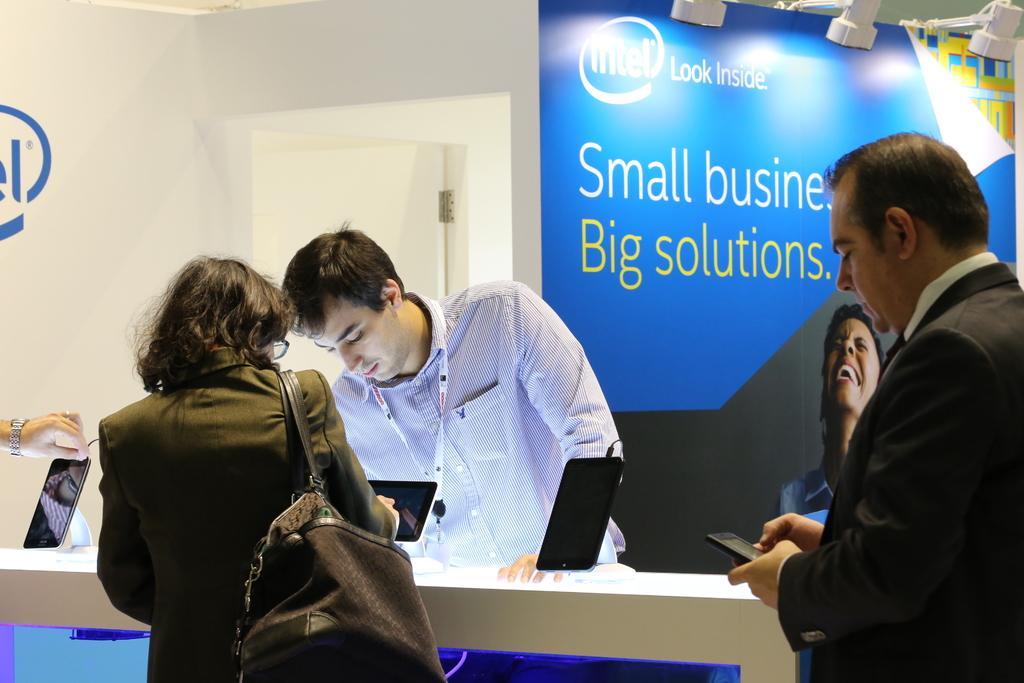In one or two sentences, can you explain what this image depicts? In this picture we can see a woman wearing bag. There are two people holding phone in their hands on the left and right side. A man is standing. There are few lights and a poster in the background. A door is visible on the left side. 